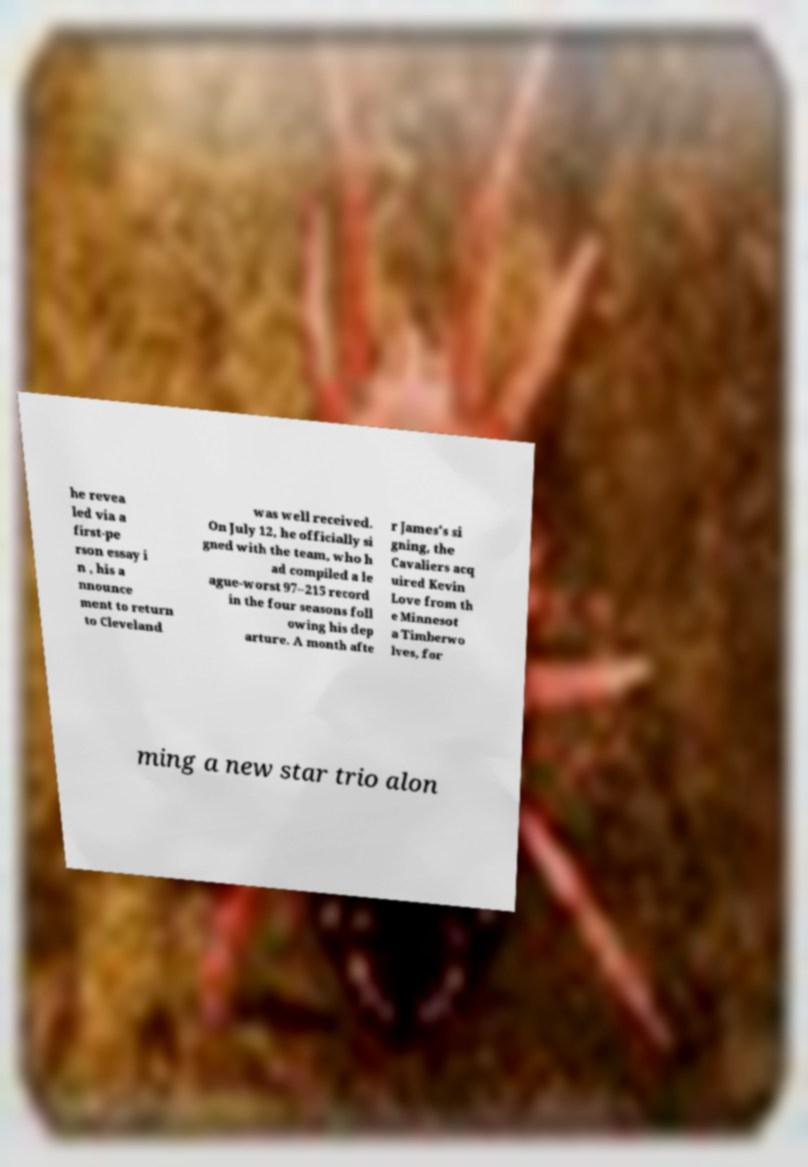There's text embedded in this image that I need extracted. Can you transcribe it verbatim? he revea led via a first-pe rson essay i n , his a nnounce ment to return to Cleveland was well received. On July 12, he officially si gned with the team, who h ad compiled a le ague-worst 97–215 record in the four seasons foll owing his dep arture. A month afte r James's si gning, the Cavaliers acq uired Kevin Love from th e Minnesot a Timberwo lves, for ming a new star trio alon 